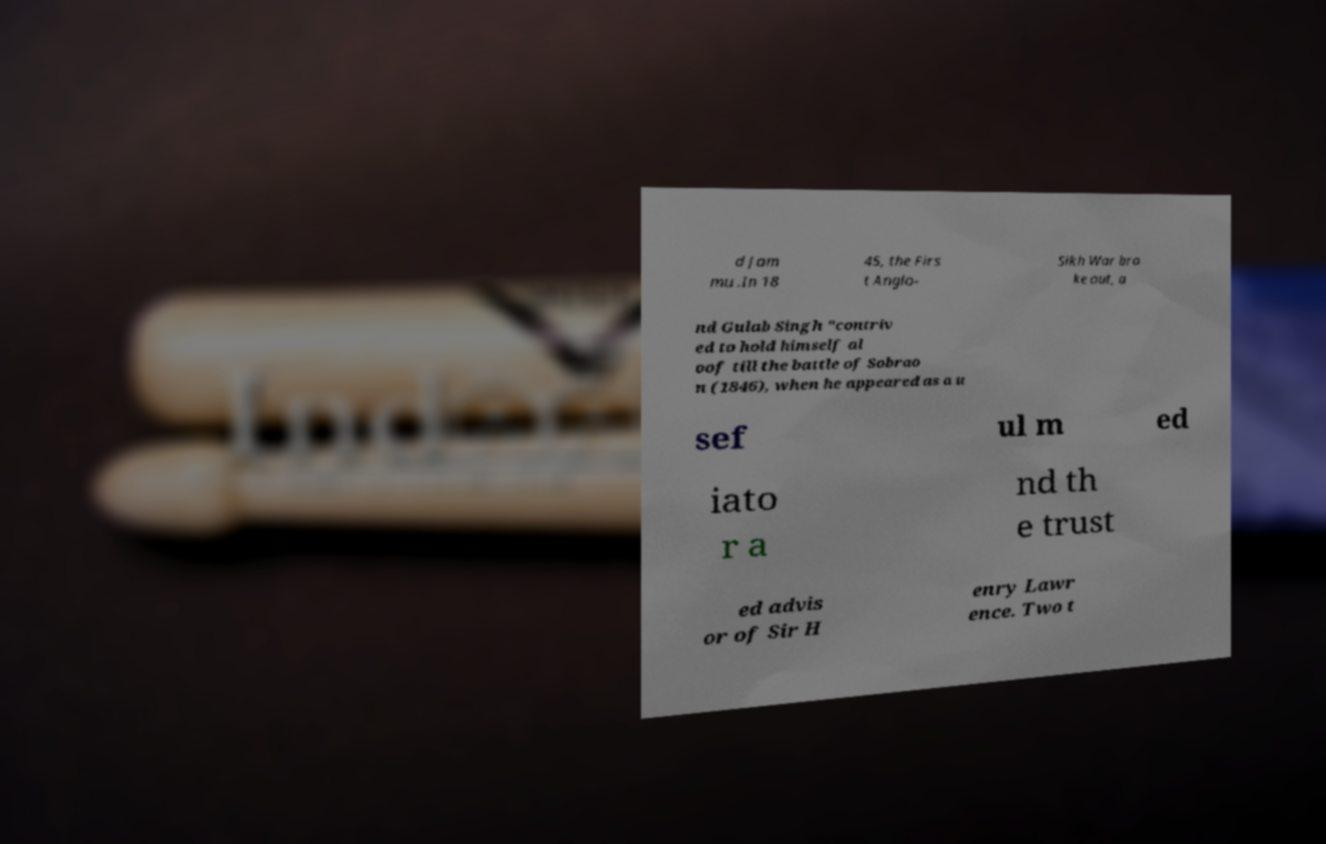Could you extract and type out the text from this image? d Jam mu .In 18 45, the Firs t Anglo- Sikh War bro ke out, a nd Gulab Singh "contriv ed to hold himself al oof till the battle of Sobrao n (1846), when he appeared as a u sef ul m ed iato r a nd th e trust ed advis or of Sir H enry Lawr ence. Two t 